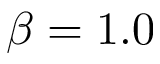Convert formula to latex. <formula><loc_0><loc_0><loc_500><loc_500>\beta = 1 . 0</formula> 